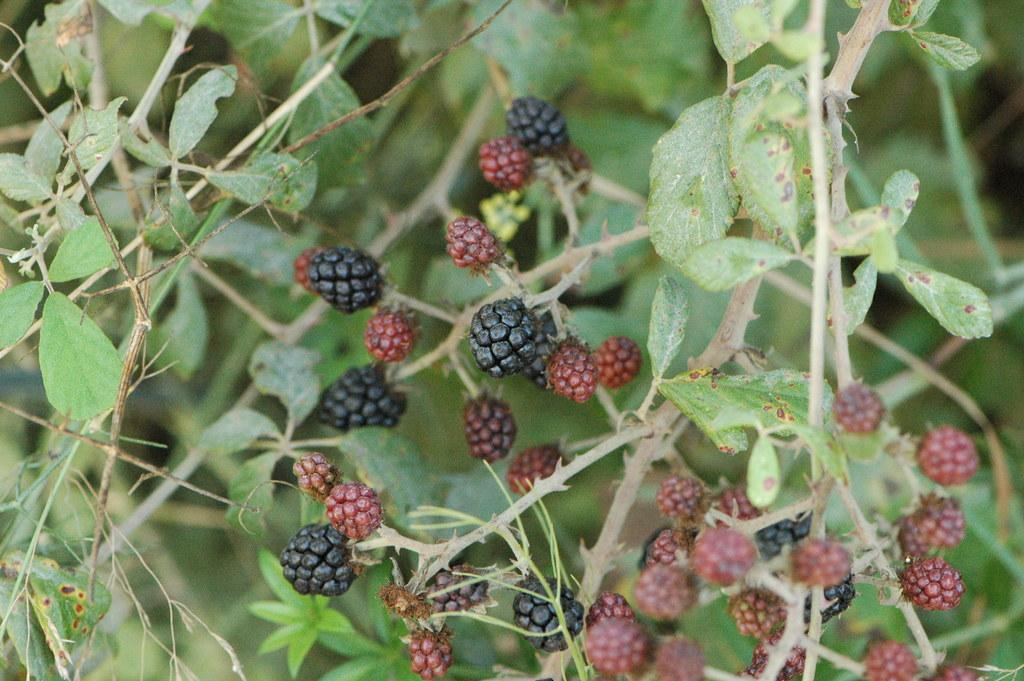What type of food can be seen in the image? There are fruits in the image. What colors are the fruits in the image? The fruits are red and black in color. What else is present in the image besides the fruits? There are plants in the image. What type of kettle is being used to recite a verse in the image? There is no kettle or verse present in the image; it only features fruits and plants. 